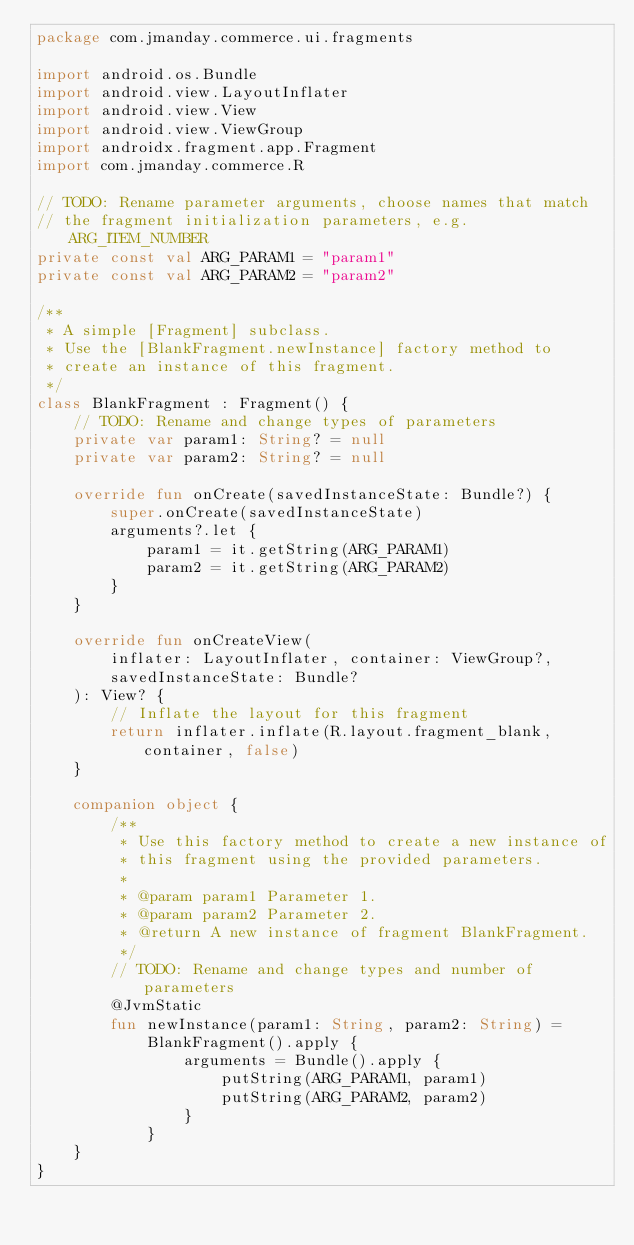Convert code to text. <code><loc_0><loc_0><loc_500><loc_500><_Kotlin_>package com.jmanday.commerce.ui.fragments

import android.os.Bundle
import android.view.LayoutInflater
import android.view.View
import android.view.ViewGroup
import androidx.fragment.app.Fragment
import com.jmanday.commerce.R

// TODO: Rename parameter arguments, choose names that match
// the fragment initialization parameters, e.g. ARG_ITEM_NUMBER
private const val ARG_PARAM1 = "param1"
private const val ARG_PARAM2 = "param2"

/**
 * A simple [Fragment] subclass.
 * Use the [BlankFragment.newInstance] factory method to
 * create an instance of this fragment.
 */
class BlankFragment : Fragment() {
    // TODO: Rename and change types of parameters
    private var param1: String? = null
    private var param2: String? = null

    override fun onCreate(savedInstanceState: Bundle?) {
        super.onCreate(savedInstanceState)
        arguments?.let {
            param1 = it.getString(ARG_PARAM1)
            param2 = it.getString(ARG_PARAM2)
        }
    }

    override fun onCreateView(
        inflater: LayoutInflater, container: ViewGroup?,
        savedInstanceState: Bundle?
    ): View? {
        // Inflate the layout for this fragment
        return inflater.inflate(R.layout.fragment_blank, container, false)
    }

    companion object {
        /**
         * Use this factory method to create a new instance of
         * this fragment using the provided parameters.
         *
         * @param param1 Parameter 1.
         * @param param2 Parameter 2.
         * @return A new instance of fragment BlankFragment.
         */
        // TODO: Rename and change types and number of parameters
        @JvmStatic
        fun newInstance(param1: String, param2: String) =
            BlankFragment().apply {
                arguments = Bundle().apply {
                    putString(ARG_PARAM1, param1)
                    putString(ARG_PARAM2, param2)
                }
            }
    }
}
</code> 